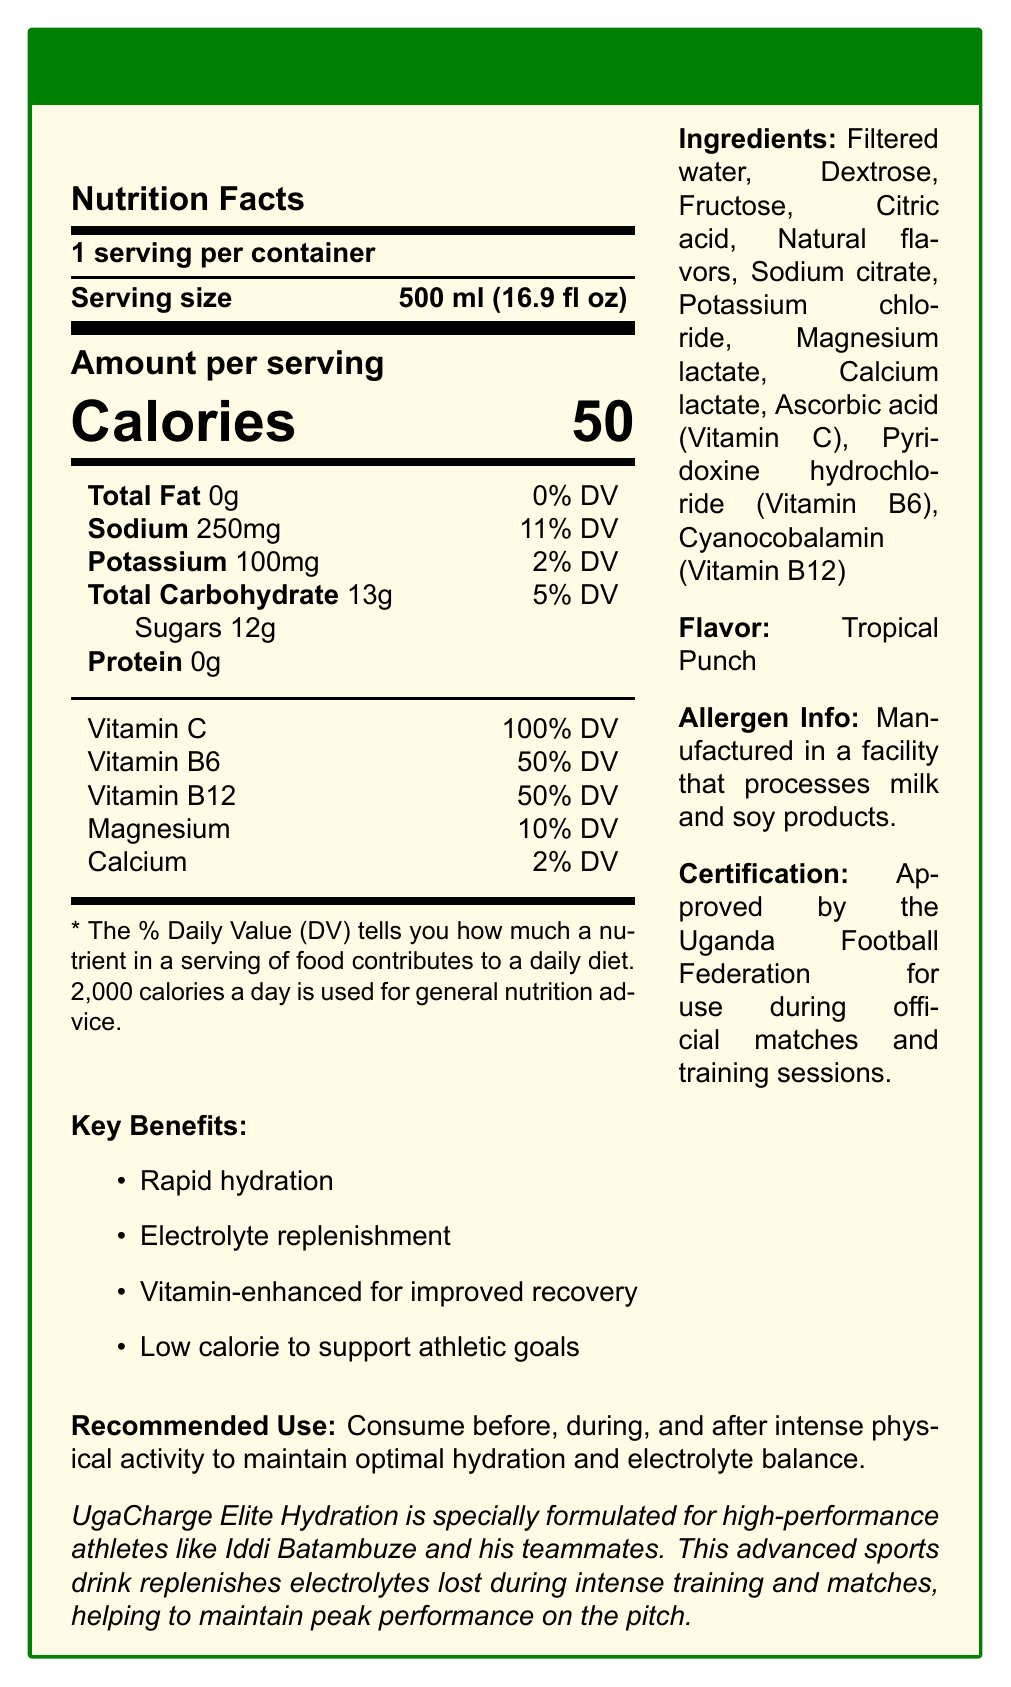what is the serving size of UgaCharge Elite Hydration? The serving size is explicitly stated in the "Nutrition Facts" section of the document.
Answer: 500 ml (16.9 fl oz) how many calories are in one serving? The document lists the calories per serving in the "Nutrition Facts" section.
Answer: 50 calories which vitamin in UgaCharge Elite Hydration is present at 50% of the daily value? The "Nutrition Facts" section shows that both Vitamin B6 and Vitamin B12 are present at 50% of the daily value.
Answer: Vitamin B6 and Vitamin B12 what is the flavor of UgaCharge Elite Hydration? The flavor is mentioned in the "Ingredients" section of the document.
Answer: Tropical Punch who is UgaCharge Elite Hydration specially formulated for? The product description states this explicitly.
Answer: High-performance athletes like Iddi Batambuze and his teammates which of the following is NOT an ingredient in UgaCharge Elite Hydration? A. Dextrose B. Fructose C. Glucose The ingredients listed in the document include Dextrose and Fructose but not Glucose.
Answer: C. Glucose what is the percentage daily value of sodium per serving? A. 5% B. 10% C. 11% D. 15% The document lists sodium as 250mg, which is 11% of the daily value.
Answer: C. 11% is UgaCharge Elite Hydration recommended for consumption only after physical activity? The recommended use states it can be consumed before, during, and after intense physical activity.
Answer: No does the document mention allergen information? The allergen information is provided, indicating the product is manufactured in a facility that processes milk and soy products.
Answer: Yes summarize the main benefits of UgaCharge Elite Hydration. These key benefits are listed in the "Key Benefits" section of the document.
Answer: Rapid hydration, electrolyte replenishment, vitamin-enhanced for improved recovery, low calorie to support athletic goals what is the cost of UgaCharge Elite Hydration per serving? The document does not provide any information regarding the cost of the product.
Answer: Cannot be determined 